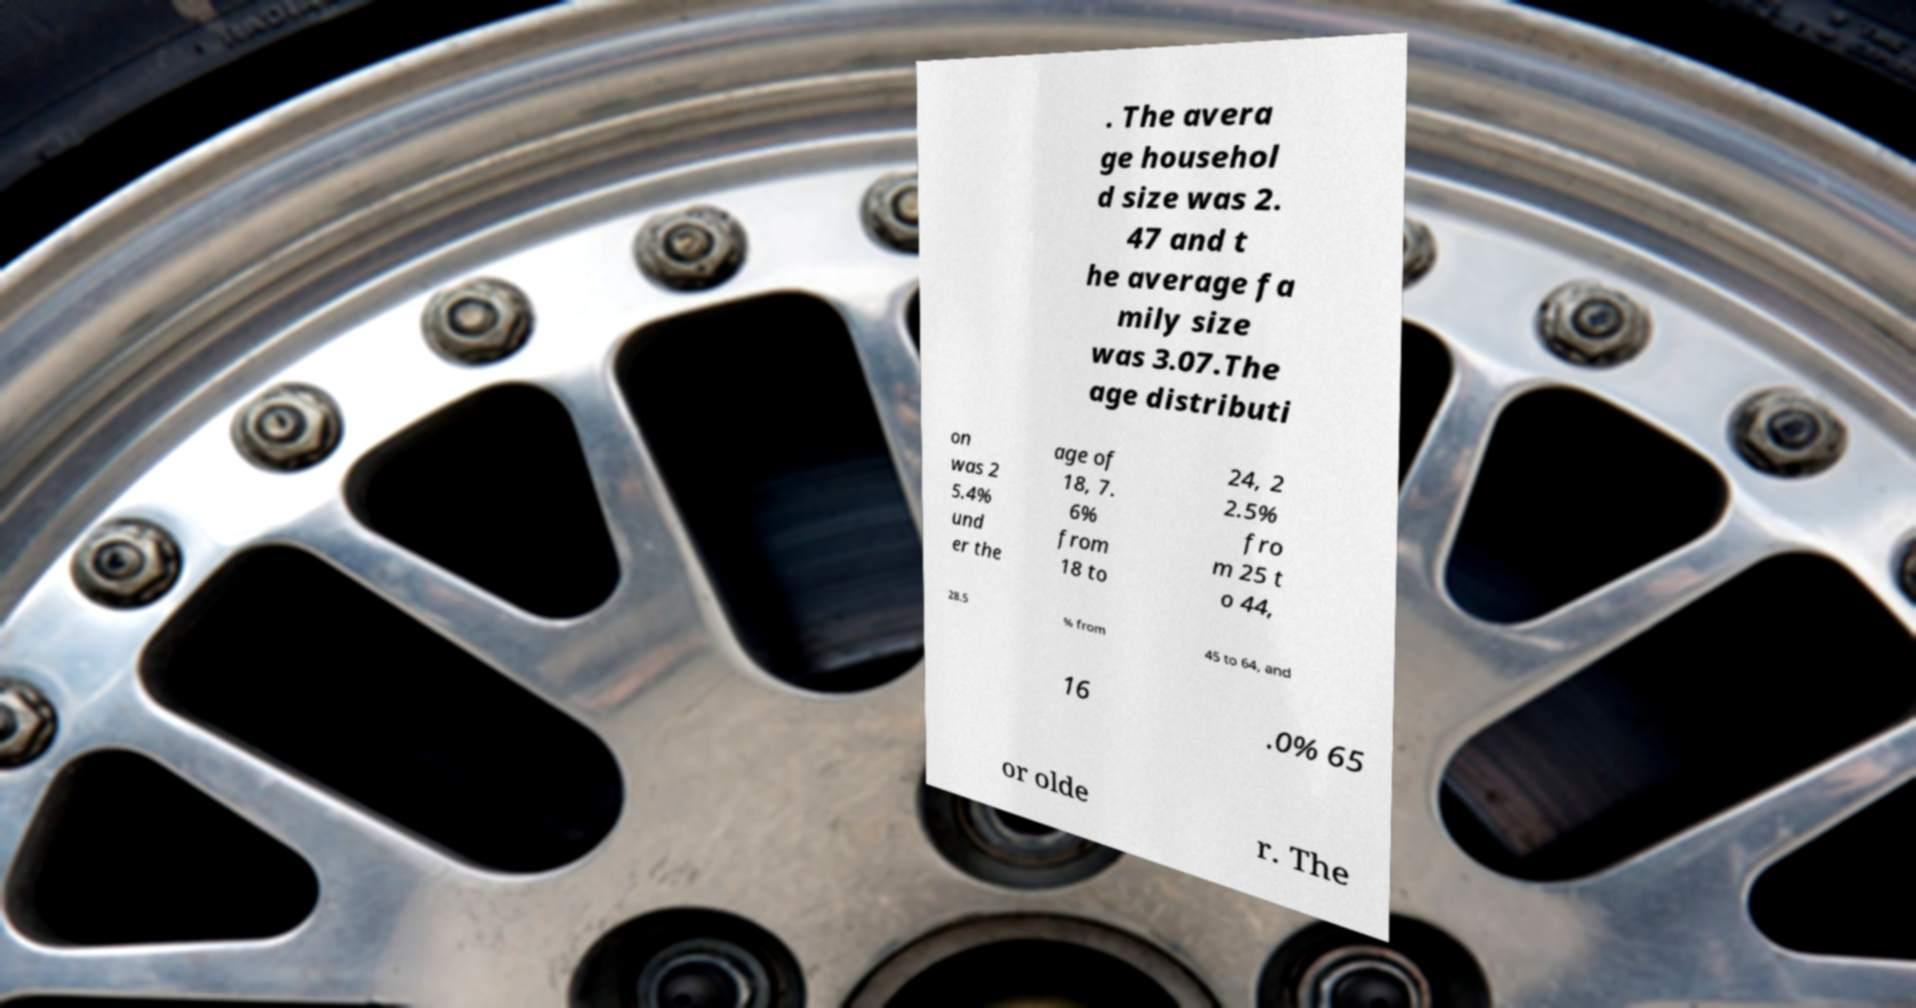There's text embedded in this image that I need extracted. Can you transcribe it verbatim? . The avera ge househol d size was 2. 47 and t he average fa mily size was 3.07.The age distributi on was 2 5.4% und er the age of 18, 7. 6% from 18 to 24, 2 2.5% fro m 25 t o 44, 28.5 % from 45 to 64, and 16 .0% 65 or olde r. The 